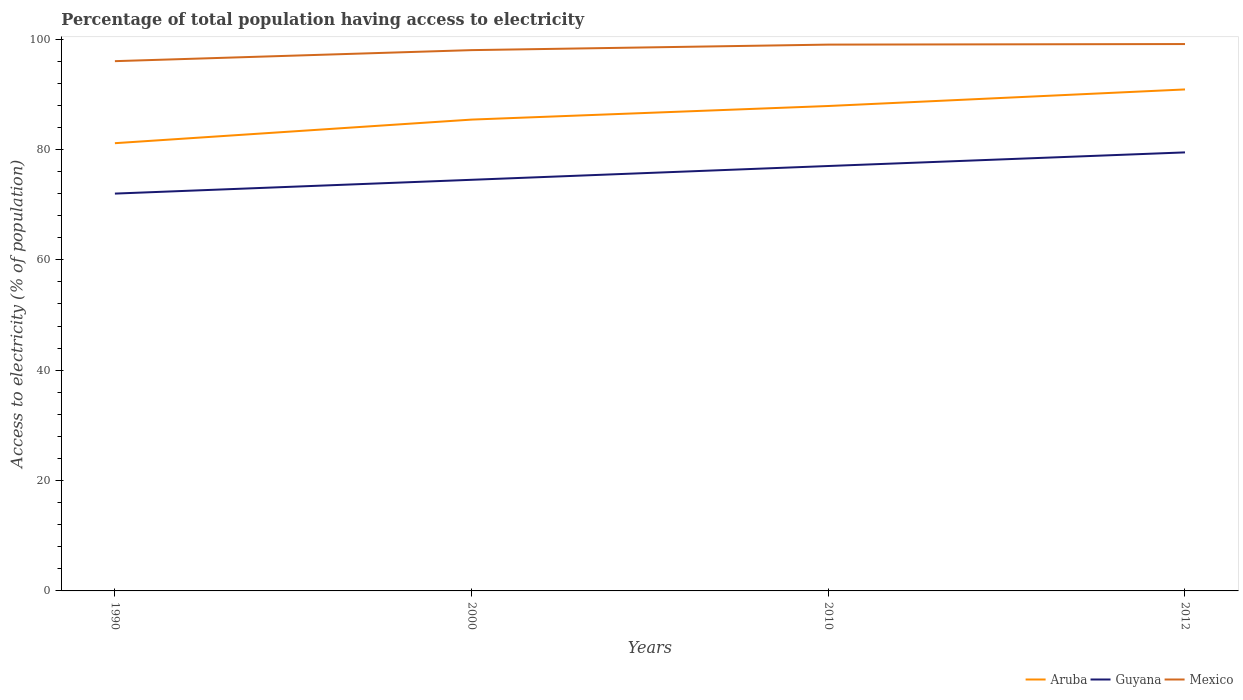Is the number of lines equal to the number of legend labels?
Your response must be concise. Yes. Across all years, what is the maximum percentage of population that have access to electricity in Aruba?
Provide a short and direct response. 81.14. In which year was the percentage of population that have access to electricity in Aruba maximum?
Offer a very short reply. 1990. What is the difference between the highest and the second highest percentage of population that have access to electricity in Aruba?
Your response must be concise. 9.74. Does the graph contain any zero values?
Offer a terse response. No. Does the graph contain grids?
Give a very brief answer. No. Where does the legend appear in the graph?
Your answer should be compact. Bottom right. How many legend labels are there?
Your answer should be very brief. 3. What is the title of the graph?
Offer a terse response. Percentage of total population having access to electricity. Does "Guatemala" appear as one of the legend labels in the graph?
Keep it short and to the point. No. What is the label or title of the Y-axis?
Offer a terse response. Access to electricity (% of population). What is the Access to electricity (% of population) in Aruba in 1990?
Make the answer very short. 81.14. What is the Access to electricity (% of population) of Mexico in 1990?
Keep it short and to the point. 96. What is the Access to electricity (% of population) of Aruba in 2000?
Your answer should be compact. 85.41. What is the Access to electricity (% of population) in Guyana in 2000?
Keep it short and to the point. 74.5. What is the Access to electricity (% of population) in Aruba in 2010?
Offer a very short reply. 87.87. What is the Access to electricity (% of population) in Aruba in 2012?
Ensure brevity in your answer.  90.88. What is the Access to electricity (% of population) in Guyana in 2012?
Your answer should be very brief. 79.47. What is the Access to electricity (% of population) in Mexico in 2012?
Your response must be concise. 99.1. Across all years, what is the maximum Access to electricity (% of population) in Aruba?
Offer a very short reply. 90.88. Across all years, what is the maximum Access to electricity (% of population) in Guyana?
Provide a succinct answer. 79.47. Across all years, what is the maximum Access to electricity (% of population) of Mexico?
Provide a succinct answer. 99.1. Across all years, what is the minimum Access to electricity (% of population) in Aruba?
Offer a very short reply. 81.14. Across all years, what is the minimum Access to electricity (% of population) of Guyana?
Provide a succinct answer. 72. Across all years, what is the minimum Access to electricity (% of population) of Mexico?
Ensure brevity in your answer.  96. What is the total Access to electricity (% of population) of Aruba in the graph?
Keep it short and to the point. 345.3. What is the total Access to electricity (% of population) in Guyana in the graph?
Keep it short and to the point. 302.97. What is the total Access to electricity (% of population) in Mexico in the graph?
Your answer should be compact. 392.1. What is the difference between the Access to electricity (% of population) in Aruba in 1990 and that in 2000?
Provide a succinct answer. -4.28. What is the difference between the Access to electricity (% of population) of Guyana in 1990 and that in 2000?
Your answer should be very brief. -2.5. What is the difference between the Access to electricity (% of population) in Aruba in 1990 and that in 2010?
Make the answer very short. -6.74. What is the difference between the Access to electricity (% of population) in Mexico in 1990 and that in 2010?
Offer a terse response. -3. What is the difference between the Access to electricity (% of population) of Aruba in 1990 and that in 2012?
Your answer should be very brief. -9.74. What is the difference between the Access to electricity (% of population) of Guyana in 1990 and that in 2012?
Make the answer very short. -7.47. What is the difference between the Access to electricity (% of population) in Mexico in 1990 and that in 2012?
Your answer should be very brief. -3.1. What is the difference between the Access to electricity (% of population) of Aruba in 2000 and that in 2010?
Your response must be concise. -2.46. What is the difference between the Access to electricity (% of population) of Aruba in 2000 and that in 2012?
Keep it short and to the point. -5.46. What is the difference between the Access to electricity (% of population) in Guyana in 2000 and that in 2012?
Your answer should be compact. -4.97. What is the difference between the Access to electricity (% of population) of Aruba in 2010 and that in 2012?
Give a very brief answer. -3. What is the difference between the Access to electricity (% of population) in Guyana in 2010 and that in 2012?
Give a very brief answer. -2.47. What is the difference between the Access to electricity (% of population) in Mexico in 2010 and that in 2012?
Keep it short and to the point. -0.1. What is the difference between the Access to electricity (% of population) in Aruba in 1990 and the Access to electricity (% of population) in Guyana in 2000?
Give a very brief answer. 6.64. What is the difference between the Access to electricity (% of population) in Aruba in 1990 and the Access to electricity (% of population) in Mexico in 2000?
Make the answer very short. -16.86. What is the difference between the Access to electricity (% of population) in Aruba in 1990 and the Access to electricity (% of population) in Guyana in 2010?
Offer a terse response. 4.14. What is the difference between the Access to electricity (% of population) of Aruba in 1990 and the Access to electricity (% of population) of Mexico in 2010?
Offer a terse response. -17.86. What is the difference between the Access to electricity (% of population) in Aruba in 1990 and the Access to electricity (% of population) in Guyana in 2012?
Ensure brevity in your answer.  1.67. What is the difference between the Access to electricity (% of population) of Aruba in 1990 and the Access to electricity (% of population) of Mexico in 2012?
Your response must be concise. -17.96. What is the difference between the Access to electricity (% of population) of Guyana in 1990 and the Access to electricity (% of population) of Mexico in 2012?
Your response must be concise. -27.1. What is the difference between the Access to electricity (% of population) of Aruba in 2000 and the Access to electricity (% of population) of Guyana in 2010?
Give a very brief answer. 8.41. What is the difference between the Access to electricity (% of population) in Aruba in 2000 and the Access to electricity (% of population) in Mexico in 2010?
Give a very brief answer. -13.59. What is the difference between the Access to electricity (% of population) of Guyana in 2000 and the Access to electricity (% of population) of Mexico in 2010?
Keep it short and to the point. -24.5. What is the difference between the Access to electricity (% of population) of Aruba in 2000 and the Access to electricity (% of population) of Guyana in 2012?
Provide a succinct answer. 5.94. What is the difference between the Access to electricity (% of population) of Aruba in 2000 and the Access to electricity (% of population) of Mexico in 2012?
Your answer should be compact. -13.69. What is the difference between the Access to electricity (% of population) of Guyana in 2000 and the Access to electricity (% of population) of Mexico in 2012?
Your answer should be compact. -24.6. What is the difference between the Access to electricity (% of population) in Aruba in 2010 and the Access to electricity (% of population) in Guyana in 2012?
Provide a succinct answer. 8.41. What is the difference between the Access to electricity (% of population) of Aruba in 2010 and the Access to electricity (% of population) of Mexico in 2012?
Give a very brief answer. -11.23. What is the difference between the Access to electricity (% of population) of Guyana in 2010 and the Access to electricity (% of population) of Mexico in 2012?
Provide a succinct answer. -22.1. What is the average Access to electricity (% of population) of Aruba per year?
Ensure brevity in your answer.  86.32. What is the average Access to electricity (% of population) of Guyana per year?
Your answer should be very brief. 75.74. What is the average Access to electricity (% of population) in Mexico per year?
Your answer should be very brief. 98.03. In the year 1990, what is the difference between the Access to electricity (% of population) in Aruba and Access to electricity (% of population) in Guyana?
Provide a short and direct response. 9.14. In the year 1990, what is the difference between the Access to electricity (% of population) in Aruba and Access to electricity (% of population) in Mexico?
Your response must be concise. -14.86. In the year 2000, what is the difference between the Access to electricity (% of population) in Aruba and Access to electricity (% of population) in Guyana?
Your response must be concise. 10.91. In the year 2000, what is the difference between the Access to electricity (% of population) in Aruba and Access to electricity (% of population) in Mexico?
Offer a terse response. -12.59. In the year 2000, what is the difference between the Access to electricity (% of population) in Guyana and Access to electricity (% of population) in Mexico?
Offer a terse response. -23.5. In the year 2010, what is the difference between the Access to electricity (% of population) in Aruba and Access to electricity (% of population) in Guyana?
Your answer should be very brief. 10.87. In the year 2010, what is the difference between the Access to electricity (% of population) in Aruba and Access to electricity (% of population) in Mexico?
Ensure brevity in your answer.  -11.13. In the year 2010, what is the difference between the Access to electricity (% of population) of Guyana and Access to electricity (% of population) of Mexico?
Your response must be concise. -22. In the year 2012, what is the difference between the Access to electricity (% of population) of Aruba and Access to electricity (% of population) of Guyana?
Your answer should be compact. 11.41. In the year 2012, what is the difference between the Access to electricity (% of population) in Aruba and Access to electricity (% of population) in Mexico?
Provide a short and direct response. -8.22. In the year 2012, what is the difference between the Access to electricity (% of population) of Guyana and Access to electricity (% of population) of Mexico?
Provide a succinct answer. -19.63. What is the ratio of the Access to electricity (% of population) in Aruba in 1990 to that in 2000?
Make the answer very short. 0.95. What is the ratio of the Access to electricity (% of population) of Guyana in 1990 to that in 2000?
Provide a succinct answer. 0.97. What is the ratio of the Access to electricity (% of population) of Mexico in 1990 to that in 2000?
Offer a terse response. 0.98. What is the ratio of the Access to electricity (% of population) in Aruba in 1990 to that in 2010?
Your answer should be compact. 0.92. What is the ratio of the Access to electricity (% of population) of Guyana in 1990 to that in 2010?
Your answer should be very brief. 0.94. What is the ratio of the Access to electricity (% of population) of Mexico in 1990 to that in 2010?
Your answer should be compact. 0.97. What is the ratio of the Access to electricity (% of population) of Aruba in 1990 to that in 2012?
Your answer should be compact. 0.89. What is the ratio of the Access to electricity (% of population) of Guyana in 1990 to that in 2012?
Offer a terse response. 0.91. What is the ratio of the Access to electricity (% of population) of Mexico in 1990 to that in 2012?
Provide a short and direct response. 0.97. What is the ratio of the Access to electricity (% of population) of Guyana in 2000 to that in 2010?
Offer a terse response. 0.97. What is the ratio of the Access to electricity (% of population) in Mexico in 2000 to that in 2010?
Your answer should be very brief. 0.99. What is the ratio of the Access to electricity (% of population) in Aruba in 2000 to that in 2012?
Your response must be concise. 0.94. What is the ratio of the Access to electricity (% of population) of Guyana in 2000 to that in 2012?
Your answer should be compact. 0.94. What is the ratio of the Access to electricity (% of population) of Mexico in 2000 to that in 2012?
Provide a succinct answer. 0.99. What is the ratio of the Access to electricity (% of population) in Aruba in 2010 to that in 2012?
Offer a terse response. 0.97. What is the ratio of the Access to electricity (% of population) in Guyana in 2010 to that in 2012?
Provide a succinct answer. 0.97. What is the ratio of the Access to electricity (% of population) of Mexico in 2010 to that in 2012?
Your answer should be very brief. 1. What is the difference between the highest and the second highest Access to electricity (% of population) of Aruba?
Offer a terse response. 3. What is the difference between the highest and the second highest Access to electricity (% of population) in Guyana?
Offer a terse response. 2.47. What is the difference between the highest and the lowest Access to electricity (% of population) of Aruba?
Ensure brevity in your answer.  9.74. What is the difference between the highest and the lowest Access to electricity (% of population) of Guyana?
Keep it short and to the point. 7.47. What is the difference between the highest and the lowest Access to electricity (% of population) in Mexico?
Offer a terse response. 3.1. 